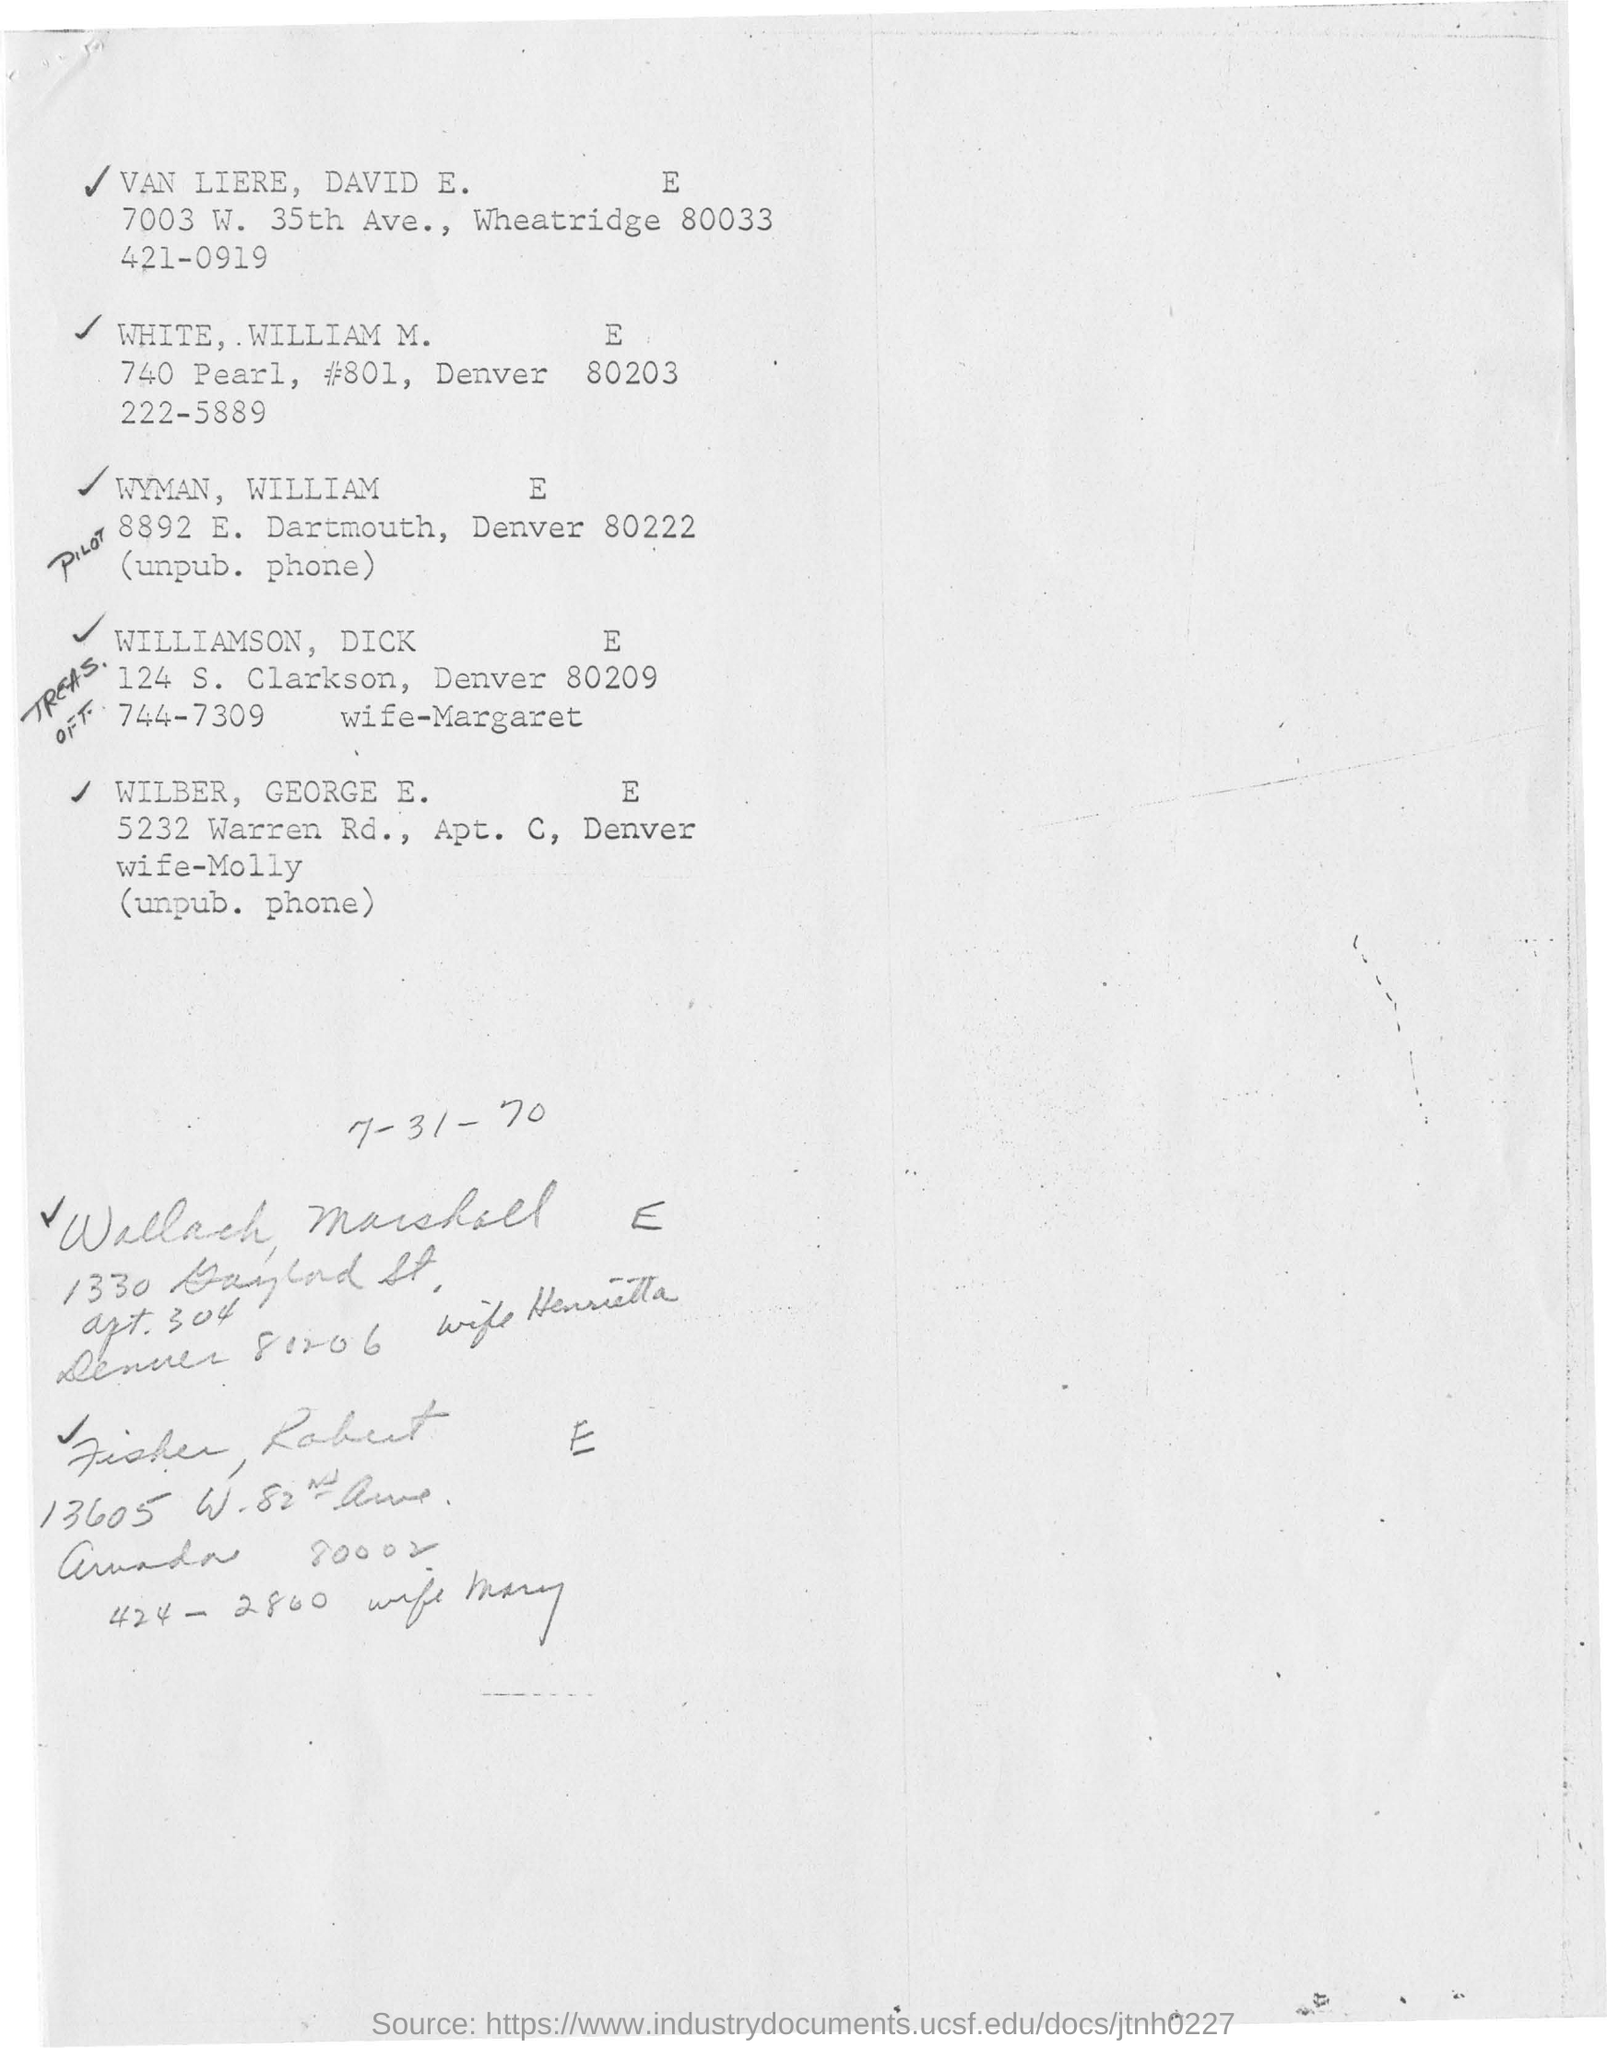What is the first name?
Keep it short and to the point. VAN LIERE, DAVID E. What is address of  WILBER, GEORGE E.?
Your answer should be compact. 5232 Warren Rd., Apt. C, Denver. What is the second person's address?
Offer a very short reply. 740 Pearl, #801, Denver 80203. 